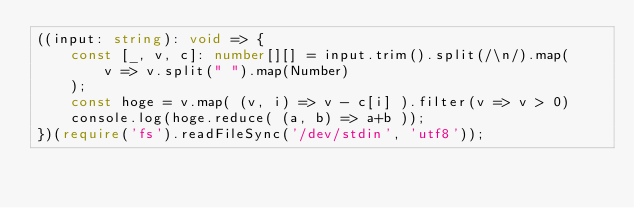Convert code to text. <code><loc_0><loc_0><loc_500><loc_500><_TypeScript_>((input: string): void => {
    const [_, v, c]: number[][] = input.trim().split(/\n/).map(
        v => v.split(" ").map(Number)
    );
    const hoge = v.map( (v, i) => v - c[i] ).filter(v => v > 0)
    console.log(hoge.reduce( (a, b) => a+b ));
})(require('fs').readFileSync('/dev/stdin', 'utf8'));</code> 